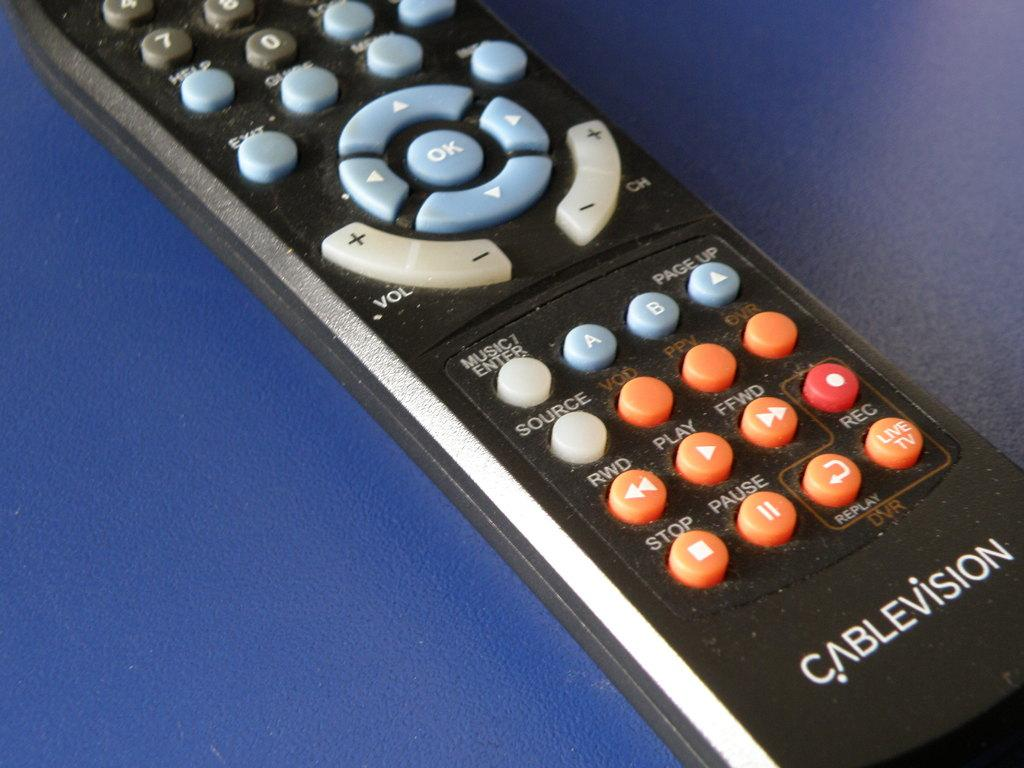<image>
Describe the image concisely. A black remote with blue and orange buttons says Cablevision on it. 